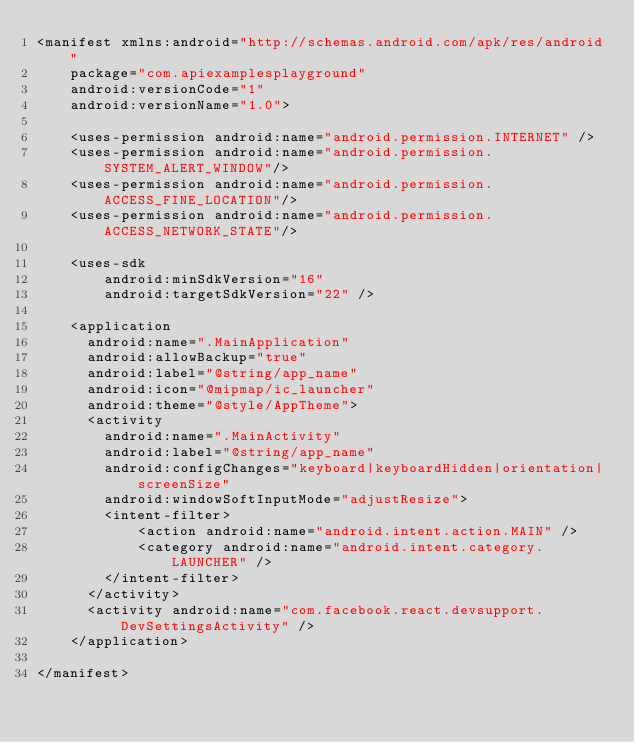Convert code to text. <code><loc_0><loc_0><loc_500><loc_500><_XML_><manifest xmlns:android="http://schemas.android.com/apk/res/android"
    package="com.apiexamplesplayground"
    android:versionCode="1"
    android:versionName="1.0">

    <uses-permission android:name="android.permission.INTERNET" />
    <uses-permission android:name="android.permission.SYSTEM_ALERT_WINDOW"/>
    <uses-permission android:name="android.permission.ACCESS_FINE_LOCATION"/>
    <uses-permission android:name="android.permission.ACCESS_NETWORK_STATE"/>

    <uses-sdk
        android:minSdkVersion="16"
        android:targetSdkVersion="22" />

    <application
      android:name=".MainApplication"
      android:allowBackup="true"
      android:label="@string/app_name"
      android:icon="@mipmap/ic_launcher"
      android:theme="@style/AppTheme">
      <activity
        android:name=".MainActivity"
        android:label="@string/app_name"
        android:configChanges="keyboard|keyboardHidden|orientation|screenSize"
        android:windowSoftInputMode="adjustResize">
        <intent-filter>
            <action android:name="android.intent.action.MAIN" />
            <category android:name="android.intent.category.LAUNCHER" />
        </intent-filter>
      </activity>
      <activity android:name="com.facebook.react.devsupport.DevSettingsActivity" />
    </application>

</manifest>
</code> 